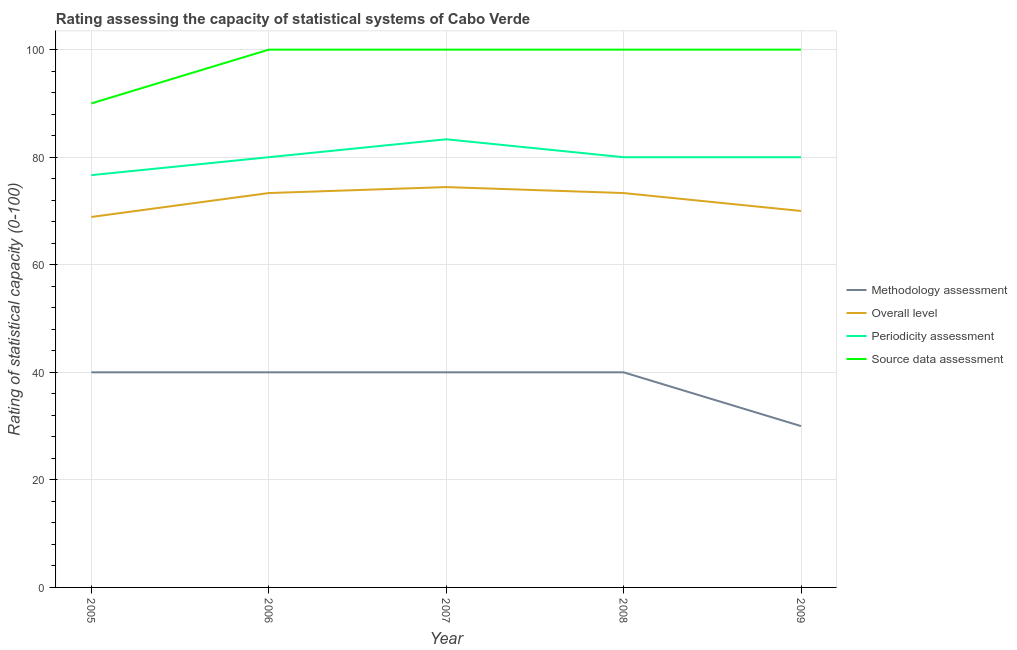Does the line corresponding to periodicity assessment rating intersect with the line corresponding to methodology assessment rating?
Offer a very short reply. No. Is the number of lines equal to the number of legend labels?
Your response must be concise. Yes. What is the periodicity assessment rating in 2006?
Provide a succinct answer. 80. Across all years, what is the maximum periodicity assessment rating?
Give a very brief answer. 83.33. Across all years, what is the minimum methodology assessment rating?
Your response must be concise. 30. In which year was the periodicity assessment rating maximum?
Your answer should be very brief. 2007. In which year was the periodicity assessment rating minimum?
Give a very brief answer. 2005. What is the difference between the methodology assessment rating in 2008 and that in 2009?
Offer a very short reply. 10. What is the difference between the methodology assessment rating in 2007 and the source data assessment rating in 2005?
Keep it short and to the point. -50. In the year 2006, what is the difference between the methodology assessment rating and periodicity assessment rating?
Provide a short and direct response. -40. What is the ratio of the overall level rating in 2005 to that in 2008?
Your answer should be compact. 0.94. Is the source data assessment rating in 2005 less than that in 2007?
Offer a very short reply. Yes. What is the difference between the highest and the lowest periodicity assessment rating?
Your answer should be compact. 6.67. In how many years, is the overall level rating greater than the average overall level rating taken over all years?
Your response must be concise. 3. Is it the case that in every year, the sum of the overall level rating and source data assessment rating is greater than the sum of periodicity assessment rating and methodology assessment rating?
Your answer should be compact. Yes. How many lines are there?
Your answer should be compact. 4. What is the difference between two consecutive major ticks on the Y-axis?
Your answer should be compact. 20. Does the graph contain any zero values?
Keep it short and to the point. No. How are the legend labels stacked?
Offer a very short reply. Vertical. What is the title of the graph?
Make the answer very short. Rating assessing the capacity of statistical systems of Cabo Verde. Does "Tertiary schools" appear as one of the legend labels in the graph?
Ensure brevity in your answer.  No. What is the label or title of the X-axis?
Provide a short and direct response. Year. What is the label or title of the Y-axis?
Ensure brevity in your answer.  Rating of statistical capacity (0-100). What is the Rating of statistical capacity (0-100) in Overall level in 2005?
Your response must be concise. 68.89. What is the Rating of statistical capacity (0-100) in Periodicity assessment in 2005?
Your answer should be very brief. 76.67. What is the Rating of statistical capacity (0-100) of Source data assessment in 2005?
Provide a succinct answer. 90. What is the Rating of statistical capacity (0-100) in Methodology assessment in 2006?
Your response must be concise. 40. What is the Rating of statistical capacity (0-100) of Overall level in 2006?
Ensure brevity in your answer.  73.33. What is the Rating of statistical capacity (0-100) in Source data assessment in 2006?
Give a very brief answer. 100. What is the Rating of statistical capacity (0-100) in Overall level in 2007?
Offer a very short reply. 74.44. What is the Rating of statistical capacity (0-100) in Periodicity assessment in 2007?
Provide a succinct answer. 83.33. What is the Rating of statistical capacity (0-100) of Source data assessment in 2007?
Offer a very short reply. 100. What is the Rating of statistical capacity (0-100) of Methodology assessment in 2008?
Offer a terse response. 40. What is the Rating of statistical capacity (0-100) of Overall level in 2008?
Offer a very short reply. 73.33. What is the Rating of statistical capacity (0-100) in Periodicity assessment in 2008?
Provide a short and direct response. 80. What is the Rating of statistical capacity (0-100) of Methodology assessment in 2009?
Your response must be concise. 30. What is the Rating of statistical capacity (0-100) of Overall level in 2009?
Provide a succinct answer. 70. What is the Rating of statistical capacity (0-100) in Periodicity assessment in 2009?
Ensure brevity in your answer.  80. What is the Rating of statistical capacity (0-100) of Source data assessment in 2009?
Your answer should be compact. 100. Across all years, what is the maximum Rating of statistical capacity (0-100) of Overall level?
Ensure brevity in your answer.  74.44. Across all years, what is the maximum Rating of statistical capacity (0-100) in Periodicity assessment?
Keep it short and to the point. 83.33. Across all years, what is the maximum Rating of statistical capacity (0-100) of Source data assessment?
Provide a short and direct response. 100. Across all years, what is the minimum Rating of statistical capacity (0-100) in Methodology assessment?
Your response must be concise. 30. Across all years, what is the minimum Rating of statistical capacity (0-100) in Overall level?
Ensure brevity in your answer.  68.89. Across all years, what is the minimum Rating of statistical capacity (0-100) of Periodicity assessment?
Offer a very short reply. 76.67. What is the total Rating of statistical capacity (0-100) in Methodology assessment in the graph?
Offer a very short reply. 190. What is the total Rating of statistical capacity (0-100) of Overall level in the graph?
Keep it short and to the point. 360. What is the total Rating of statistical capacity (0-100) in Periodicity assessment in the graph?
Ensure brevity in your answer.  400. What is the total Rating of statistical capacity (0-100) in Source data assessment in the graph?
Offer a very short reply. 490. What is the difference between the Rating of statistical capacity (0-100) of Overall level in 2005 and that in 2006?
Ensure brevity in your answer.  -4.44. What is the difference between the Rating of statistical capacity (0-100) in Periodicity assessment in 2005 and that in 2006?
Offer a very short reply. -3.33. What is the difference between the Rating of statistical capacity (0-100) of Source data assessment in 2005 and that in 2006?
Provide a short and direct response. -10. What is the difference between the Rating of statistical capacity (0-100) of Methodology assessment in 2005 and that in 2007?
Make the answer very short. 0. What is the difference between the Rating of statistical capacity (0-100) in Overall level in 2005 and that in 2007?
Keep it short and to the point. -5.56. What is the difference between the Rating of statistical capacity (0-100) of Periodicity assessment in 2005 and that in 2007?
Your answer should be compact. -6.67. What is the difference between the Rating of statistical capacity (0-100) in Source data assessment in 2005 and that in 2007?
Your response must be concise. -10. What is the difference between the Rating of statistical capacity (0-100) of Methodology assessment in 2005 and that in 2008?
Provide a succinct answer. 0. What is the difference between the Rating of statistical capacity (0-100) in Overall level in 2005 and that in 2008?
Keep it short and to the point. -4.44. What is the difference between the Rating of statistical capacity (0-100) of Methodology assessment in 2005 and that in 2009?
Keep it short and to the point. 10. What is the difference between the Rating of statistical capacity (0-100) in Overall level in 2005 and that in 2009?
Provide a short and direct response. -1.11. What is the difference between the Rating of statistical capacity (0-100) in Overall level in 2006 and that in 2007?
Provide a short and direct response. -1.11. What is the difference between the Rating of statistical capacity (0-100) of Overall level in 2006 and that in 2008?
Offer a very short reply. 0. What is the difference between the Rating of statistical capacity (0-100) in Periodicity assessment in 2006 and that in 2008?
Keep it short and to the point. 0. What is the difference between the Rating of statistical capacity (0-100) of Overall level in 2006 and that in 2009?
Your answer should be compact. 3.33. What is the difference between the Rating of statistical capacity (0-100) of Periodicity assessment in 2006 and that in 2009?
Provide a succinct answer. 0. What is the difference between the Rating of statistical capacity (0-100) of Periodicity assessment in 2007 and that in 2008?
Your response must be concise. 3.33. What is the difference between the Rating of statistical capacity (0-100) of Overall level in 2007 and that in 2009?
Your answer should be very brief. 4.44. What is the difference between the Rating of statistical capacity (0-100) of Periodicity assessment in 2007 and that in 2009?
Your answer should be very brief. 3.33. What is the difference between the Rating of statistical capacity (0-100) in Methodology assessment in 2008 and that in 2009?
Provide a succinct answer. 10. What is the difference between the Rating of statistical capacity (0-100) of Periodicity assessment in 2008 and that in 2009?
Ensure brevity in your answer.  0. What is the difference between the Rating of statistical capacity (0-100) of Methodology assessment in 2005 and the Rating of statistical capacity (0-100) of Overall level in 2006?
Your response must be concise. -33.33. What is the difference between the Rating of statistical capacity (0-100) of Methodology assessment in 2005 and the Rating of statistical capacity (0-100) of Source data assessment in 2006?
Your answer should be very brief. -60. What is the difference between the Rating of statistical capacity (0-100) in Overall level in 2005 and the Rating of statistical capacity (0-100) in Periodicity assessment in 2006?
Give a very brief answer. -11.11. What is the difference between the Rating of statistical capacity (0-100) in Overall level in 2005 and the Rating of statistical capacity (0-100) in Source data assessment in 2006?
Ensure brevity in your answer.  -31.11. What is the difference between the Rating of statistical capacity (0-100) of Periodicity assessment in 2005 and the Rating of statistical capacity (0-100) of Source data assessment in 2006?
Provide a short and direct response. -23.33. What is the difference between the Rating of statistical capacity (0-100) in Methodology assessment in 2005 and the Rating of statistical capacity (0-100) in Overall level in 2007?
Your response must be concise. -34.44. What is the difference between the Rating of statistical capacity (0-100) of Methodology assessment in 2005 and the Rating of statistical capacity (0-100) of Periodicity assessment in 2007?
Your response must be concise. -43.33. What is the difference between the Rating of statistical capacity (0-100) in Methodology assessment in 2005 and the Rating of statistical capacity (0-100) in Source data assessment in 2007?
Give a very brief answer. -60. What is the difference between the Rating of statistical capacity (0-100) in Overall level in 2005 and the Rating of statistical capacity (0-100) in Periodicity assessment in 2007?
Your answer should be compact. -14.44. What is the difference between the Rating of statistical capacity (0-100) of Overall level in 2005 and the Rating of statistical capacity (0-100) of Source data assessment in 2007?
Provide a short and direct response. -31.11. What is the difference between the Rating of statistical capacity (0-100) of Periodicity assessment in 2005 and the Rating of statistical capacity (0-100) of Source data assessment in 2007?
Offer a very short reply. -23.33. What is the difference between the Rating of statistical capacity (0-100) of Methodology assessment in 2005 and the Rating of statistical capacity (0-100) of Overall level in 2008?
Give a very brief answer. -33.33. What is the difference between the Rating of statistical capacity (0-100) in Methodology assessment in 2005 and the Rating of statistical capacity (0-100) in Source data assessment in 2008?
Your answer should be compact. -60. What is the difference between the Rating of statistical capacity (0-100) in Overall level in 2005 and the Rating of statistical capacity (0-100) in Periodicity assessment in 2008?
Provide a succinct answer. -11.11. What is the difference between the Rating of statistical capacity (0-100) in Overall level in 2005 and the Rating of statistical capacity (0-100) in Source data assessment in 2008?
Provide a short and direct response. -31.11. What is the difference between the Rating of statistical capacity (0-100) in Periodicity assessment in 2005 and the Rating of statistical capacity (0-100) in Source data assessment in 2008?
Give a very brief answer. -23.33. What is the difference between the Rating of statistical capacity (0-100) of Methodology assessment in 2005 and the Rating of statistical capacity (0-100) of Periodicity assessment in 2009?
Your answer should be very brief. -40. What is the difference between the Rating of statistical capacity (0-100) of Methodology assessment in 2005 and the Rating of statistical capacity (0-100) of Source data assessment in 2009?
Offer a terse response. -60. What is the difference between the Rating of statistical capacity (0-100) of Overall level in 2005 and the Rating of statistical capacity (0-100) of Periodicity assessment in 2009?
Your response must be concise. -11.11. What is the difference between the Rating of statistical capacity (0-100) in Overall level in 2005 and the Rating of statistical capacity (0-100) in Source data assessment in 2009?
Ensure brevity in your answer.  -31.11. What is the difference between the Rating of statistical capacity (0-100) of Periodicity assessment in 2005 and the Rating of statistical capacity (0-100) of Source data assessment in 2009?
Make the answer very short. -23.33. What is the difference between the Rating of statistical capacity (0-100) in Methodology assessment in 2006 and the Rating of statistical capacity (0-100) in Overall level in 2007?
Give a very brief answer. -34.44. What is the difference between the Rating of statistical capacity (0-100) in Methodology assessment in 2006 and the Rating of statistical capacity (0-100) in Periodicity assessment in 2007?
Give a very brief answer. -43.33. What is the difference between the Rating of statistical capacity (0-100) in Methodology assessment in 2006 and the Rating of statistical capacity (0-100) in Source data assessment in 2007?
Make the answer very short. -60. What is the difference between the Rating of statistical capacity (0-100) in Overall level in 2006 and the Rating of statistical capacity (0-100) in Source data assessment in 2007?
Provide a succinct answer. -26.67. What is the difference between the Rating of statistical capacity (0-100) in Periodicity assessment in 2006 and the Rating of statistical capacity (0-100) in Source data assessment in 2007?
Keep it short and to the point. -20. What is the difference between the Rating of statistical capacity (0-100) in Methodology assessment in 2006 and the Rating of statistical capacity (0-100) in Overall level in 2008?
Your response must be concise. -33.33. What is the difference between the Rating of statistical capacity (0-100) of Methodology assessment in 2006 and the Rating of statistical capacity (0-100) of Periodicity assessment in 2008?
Give a very brief answer. -40. What is the difference between the Rating of statistical capacity (0-100) in Methodology assessment in 2006 and the Rating of statistical capacity (0-100) in Source data assessment in 2008?
Offer a very short reply. -60. What is the difference between the Rating of statistical capacity (0-100) of Overall level in 2006 and the Rating of statistical capacity (0-100) of Periodicity assessment in 2008?
Provide a short and direct response. -6.67. What is the difference between the Rating of statistical capacity (0-100) of Overall level in 2006 and the Rating of statistical capacity (0-100) of Source data assessment in 2008?
Offer a very short reply. -26.67. What is the difference between the Rating of statistical capacity (0-100) of Methodology assessment in 2006 and the Rating of statistical capacity (0-100) of Periodicity assessment in 2009?
Your answer should be very brief. -40. What is the difference between the Rating of statistical capacity (0-100) of Methodology assessment in 2006 and the Rating of statistical capacity (0-100) of Source data assessment in 2009?
Provide a succinct answer. -60. What is the difference between the Rating of statistical capacity (0-100) in Overall level in 2006 and the Rating of statistical capacity (0-100) in Periodicity assessment in 2009?
Give a very brief answer. -6.67. What is the difference between the Rating of statistical capacity (0-100) of Overall level in 2006 and the Rating of statistical capacity (0-100) of Source data assessment in 2009?
Offer a terse response. -26.67. What is the difference between the Rating of statistical capacity (0-100) in Periodicity assessment in 2006 and the Rating of statistical capacity (0-100) in Source data assessment in 2009?
Provide a short and direct response. -20. What is the difference between the Rating of statistical capacity (0-100) of Methodology assessment in 2007 and the Rating of statistical capacity (0-100) of Overall level in 2008?
Your response must be concise. -33.33. What is the difference between the Rating of statistical capacity (0-100) in Methodology assessment in 2007 and the Rating of statistical capacity (0-100) in Periodicity assessment in 2008?
Keep it short and to the point. -40. What is the difference between the Rating of statistical capacity (0-100) in Methodology assessment in 2007 and the Rating of statistical capacity (0-100) in Source data assessment in 2008?
Your answer should be very brief. -60. What is the difference between the Rating of statistical capacity (0-100) in Overall level in 2007 and the Rating of statistical capacity (0-100) in Periodicity assessment in 2008?
Give a very brief answer. -5.56. What is the difference between the Rating of statistical capacity (0-100) of Overall level in 2007 and the Rating of statistical capacity (0-100) of Source data assessment in 2008?
Your response must be concise. -25.56. What is the difference between the Rating of statistical capacity (0-100) of Periodicity assessment in 2007 and the Rating of statistical capacity (0-100) of Source data assessment in 2008?
Provide a short and direct response. -16.67. What is the difference between the Rating of statistical capacity (0-100) in Methodology assessment in 2007 and the Rating of statistical capacity (0-100) in Overall level in 2009?
Offer a very short reply. -30. What is the difference between the Rating of statistical capacity (0-100) of Methodology assessment in 2007 and the Rating of statistical capacity (0-100) of Source data assessment in 2009?
Your answer should be very brief. -60. What is the difference between the Rating of statistical capacity (0-100) of Overall level in 2007 and the Rating of statistical capacity (0-100) of Periodicity assessment in 2009?
Offer a terse response. -5.56. What is the difference between the Rating of statistical capacity (0-100) of Overall level in 2007 and the Rating of statistical capacity (0-100) of Source data assessment in 2009?
Your response must be concise. -25.56. What is the difference between the Rating of statistical capacity (0-100) in Periodicity assessment in 2007 and the Rating of statistical capacity (0-100) in Source data assessment in 2009?
Give a very brief answer. -16.67. What is the difference between the Rating of statistical capacity (0-100) in Methodology assessment in 2008 and the Rating of statistical capacity (0-100) in Overall level in 2009?
Ensure brevity in your answer.  -30. What is the difference between the Rating of statistical capacity (0-100) in Methodology assessment in 2008 and the Rating of statistical capacity (0-100) in Periodicity assessment in 2009?
Give a very brief answer. -40. What is the difference between the Rating of statistical capacity (0-100) of Methodology assessment in 2008 and the Rating of statistical capacity (0-100) of Source data assessment in 2009?
Provide a short and direct response. -60. What is the difference between the Rating of statistical capacity (0-100) of Overall level in 2008 and the Rating of statistical capacity (0-100) of Periodicity assessment in 2009?
Provide a short and direct response. -6.67. What is the difference between the Rating of statistical capacity (0-100) in Overall level in 2008 and the Rating of statistical capacity (0-100) in Source data assessment in 2009?
Offer a very short reply. -26.67. What is the difference between the Rating of statistical capacity (0-100) of Periodicity assessment in 2008 and the Rating of statistical capacity (0-100) of Source data assessment in 2009?
Offer a terse response. -20. What is the average Rating of statistical capacity (0-100) in Source data assessment per year?
Provide a succinct answer. 98. In the year 2005, what is the difference between the Rating of statistical capacity (0-100) of Methodology assessment and Rating of statistical capacity (0-100) of Overall level?
Keep it short and to the point. -28.89. In the year 2005, what is the difference between the Rating of statistical capacity (0-100) of Methodology assessment and Rating of statistical capacity (0-100) of Periodicity assessment?
Keep it short and to the point. -36.67. In the year 2005, what is the difference between the Rating of statistical capacity (0-100) in Overall level and Rating of statistical capacity (0-100) in Periodicity assessment?
Provide a succinct answer. -7.78. In the year 2005, what is the difference between the Rating of statistical capacity (0-100) of Overall level and Rating of statistical capacity (0-100) of Source data assessment?
Make the answer very short. -21.11. In the year 2005, what is the difference between the Rating of statistical capacity (0-100) of Periodicity assessment and Rating of statistical capacity (0-100) of Source data assessment?
Offer a terse response. -13.33. In the year 2006, what is the difference between the Rating of statistical capacity (0-100) in Methodology assessment and Rating of statistical capacity (0-100) in Overall level?
Offer a very short reply. -33.33. In the year 2006, what is the difference between the Rating of statistical capacity (0-100) in Methodology assessment and Rating of statistical capacity (0-100) in Periodicity assessment?
Provide a succinct answer. -40. In the year 2006, what is the difference between the Rating of statistical capacity (0-100) in Methodology assessment and Rating of statistical capacity (0-100) in Source data assessment?
Your answer should be very brief. -60. In the year 2006, what is the difference between the Rating of statistical capacity (0-100) of Overall level and Rating of statistical capacity (0-100) of Periodicity assessment?
Provide a short and direct response. -6.67. In the year 2006, what is the difference between the Rating of statistical capacity (0-100) of Overall level and Rating of statistical capacity (0-100) of Source data assessment?
Ensure brevity in your answer.  -26.67. In the year 2007, what is the difference between the Rating of statistical capacity (0-100) of Methodology assessment and Rating of statistical capacity (0-100) of Overall level?
Provide a succinct answer. -34.44. In the year 2007, what is the difference between the Rating of statistical capacity (0-100) in Methodology assessment and Rating of statistical capacity (0-100) in Periodicity assessment?
Give a very brief answer. -43.33. In the year 2007, what is the difference between the Rating of statistical capacity (0-100) in Methodology assessment and Rating of statistical capacity (0-100) in Source data assessment?
Your answer should be very brief. -60. In the year 2007, what is the difference between the Rating of statistical capacity (0-100) in Overall level and Rating of statistical capacity (0-100) in Periodicity assessment?
Ensure brevity in your answer.  -8.89. In the year 2007, what is the difference between the Rating of statistical capacity (0-100) in Overall level and Rating of statistical capacity (0-100) in Source data assessment?
Provide a succinct answer. -25.56. In the year 2007, what is the difference between the Rating of statistical capacity (0-100) in Periodicity assessment and Rating of statistical capacity (0-100) in Source data assessment?
Keep it short and to the point. -16.67. In the year 2008, what is the difference between the Rating of statistical capacity (0-100) of Methodology assessment and Rating of statistical capacity (0-100) of Overall level?
Provide a short and direct response. -33.33. In the year 2008, what is the difference between the Rating of statistical capacity (0-100) of Methodology assessment and Rating of statistical capacity (0-100) of Periodicity assessment?
Provide a short and direct response. -40. In the year 2008, what is the difference between the Rating of statistical capacity (0-100) of Methodology assessment and Rating of statistical capacity (0-100) of Source data assessment?
Make the answer very short. -60. In the year 2008, what is the difference between the Rating of statistical capacity (0-100) in Overall level and Rating of statistical capacity (0-100) in Periodicity assessment?
Keep it short and to the point. -6.67. In the year 2008, what is the difference between the Rating of statistical capacity (0-100) of Overall level and Rating of statistical capacity (0-100) of Source data assessment?
Your answer should be very brief. -26.67. In the year 2008, what is the difference between the Rating of statistical capacity (0-100) of Periodicity assessment and Rating of statistical capacity (0-100) of Source data assessment?
Your answer should be very brief. -20. In the year 2009, what is the difference between the Rating of statistical capacity (0-100) in Methodology assessment and Rating of statistical capacity (0-100) in Source data assessment?
Keep it short and to the point. -70. In the year 2009, what is the difference between the Rating of statistical capacity (0-100) in Overall level and Rating of statistical capacity (0-100) in Periodicity assessment?
Offer a very short reply. -10. In the year 2009, what is the difference between the Rating of statistical capacity (0-100) of Overall level and Rating of statistical capacity (0-100) of Source data assessment?
Your answer should be very brief. -30. In the year 2009, what is the difference between the Rating of statistical capacity (0-100) in Periodicity assessment and Rating of statistical capacity (0-100) in Source data assessment?
Offer a terse response. -20. What is the ratio of the Rating of statistical capacity (0-100) of Overall level in 2005 to that in 2006?
Your answer should be compact. 0.94. What is the ratio of the Rating of statistical capacity (0-100) in Source data assessment in 2005 to that in 2006?
Provide a short and direct response. 0.9. What is the ratio of the Rating of statistical capacity (0-100) of Methodology assessment in 2005 to that in 2007?
Make the answer very short. 1. What is the ratio of the Rating of statistical capacity (0-100) of Overall level in 2005 to that in 2007?
Make the answer very short. 0.93. What is the ratio of the Rating of statistical capacity (0-100) in Overall level in 2005 to that in 2008?
Make the answer very short. 0.94. What is the ratio of the Rating of statistical capacity (0-100) in Source data assessment in 2005 to that in 2008?
Offer a very short reply. 0.9. What is the ratio of the Rating of statistical capacity (0-100) of Methodology assessment in 2005 to that in 2009?
Provide a succinct answer. 1.33. What is the ratio of the Rating of statistical capacity (0-100) of Overall level in 2005 to that in 2009?
Give a very brief answer. 0.98. What is the ratio of the Rating of statistical capacity (0-100) in Periodicity assessment in 2005 to that in 2009?
Ensure brevity in your answer.  0.96. What is the ratio of the Rating of statistical capacity (0-100) of Source data assessment in 2005 to that in 2009?
Make the answer very short. 0.9. What is the ratio of the Rating of statistical capacity (0-100) of Methodology assessment in 2006 to that in 2007?
Provide a succinct answer. 1. What is the ratio of the Rating of statistical capacity (0-100) of Overall level in 2006 to that in 2007?
Your response must be concise. 0.99. What is the ratio of the Rating of statistical capacity (0-100) in Source data assessment in 2006 to that in 2007?
Make the answer very short. 1. What is the ratio of the Rating of statistical capacity (0-100) in Methodology assessment in 2006 to that in 2008?
Give a very brief answer. 1. What is the ratio of the Rating of statistical capacity (0-100) in Overall level in 2006 to that in 2008?
Provide a succinct answer. 1. What is the ratio of the Rating of statistical capacity (0-100) of Source data assessment in 2006 to that in 2008?
Give a very brief answer. 1. What is the ratio of the Rating of statistical capacity (0-100) of Overall level in 2006 to that in 2009?
Provide a short and direct response. 1.05. What is the ratio of the Rating of statistical capacity (0-100) in Periodicity assessment in 2006 to that in 2009?
Ensure brevity in your answer.  1. What is the ratio of the Rating of statistical capacity (0-100) of Overall level in 2007 to that in 2008?
Give a very brief answer. 1.02. What is the ratio of the Rating of statistical capacity (0-100) in Periodicity assessment in 2007 to that in 2008?
Keep it short and to the point. 1.04. What is the ratio of the Rating of statistical capacity (0-100) in Overall level in 2007 to that in 2009?
Provide a succinct answer. 1.06. What is the ratio of the Rating of statistical capacity (0-100) of Periodicity assessment in 2007 to that in 2009?
Give a very brief answer. 1.04. What is the ratio of the Rating of statistical capacity (0-100) in Overall level in 2008 to that in 2009?
Your answer should be very brief. 1.05. What is the ratio of the Rating of statistical capacity (0-100) in Periodicity assessment in 2008 to that in 2009?
Keep it short and to the point. 1. What is the difference between the highest and the second highest Rating of statistical capacity (0-100) of Overall level?
Your answer should be compact. 1.11. What is the difference between the highest and the second highest Rating of statistical capacity (0-100) of Periodicity assessment?
Ensure brevity in your answer.  3.33. What is the difference between the highest and the lowest Rating of statistical capacity (0-100) of Methodology assessment?
Give a very brief answer. 10. What is the difference between the highest and the lowest Rating of statistical capacity (0-100) in Overall level?
Provide a short and direct response. 5.56. What is the difference between the highest and the lowest Rating of statistical capacity (0-100) of Periodicity assessment?
Offer a terse response. 6.67. 